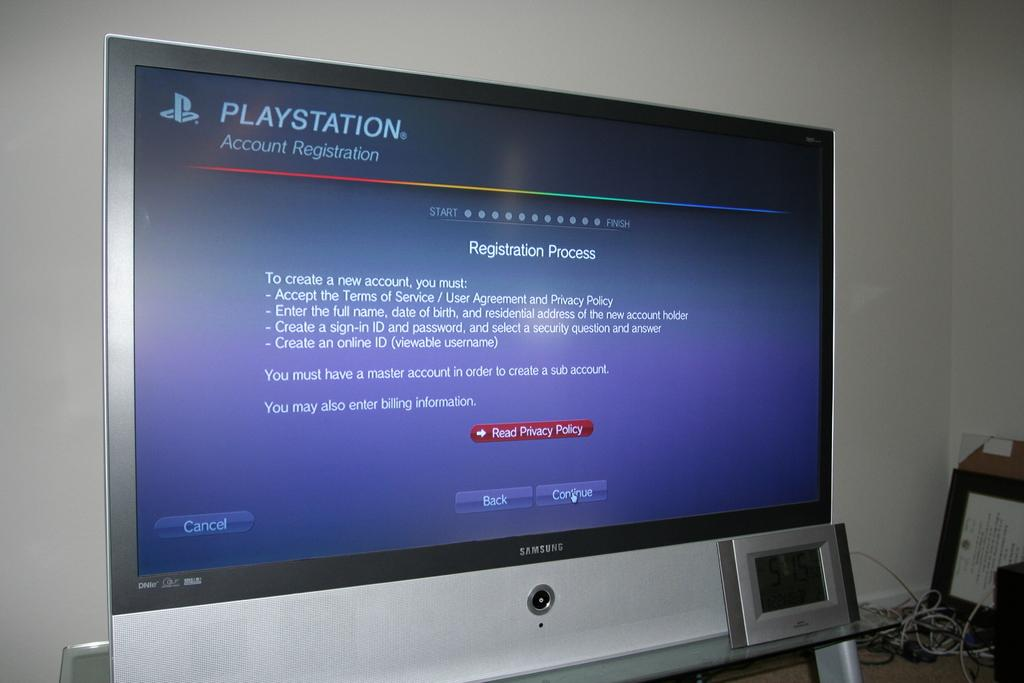<image>
Relay a brief, clear account of the picture shown. A television displaying a Playstation Account Registration screen. 